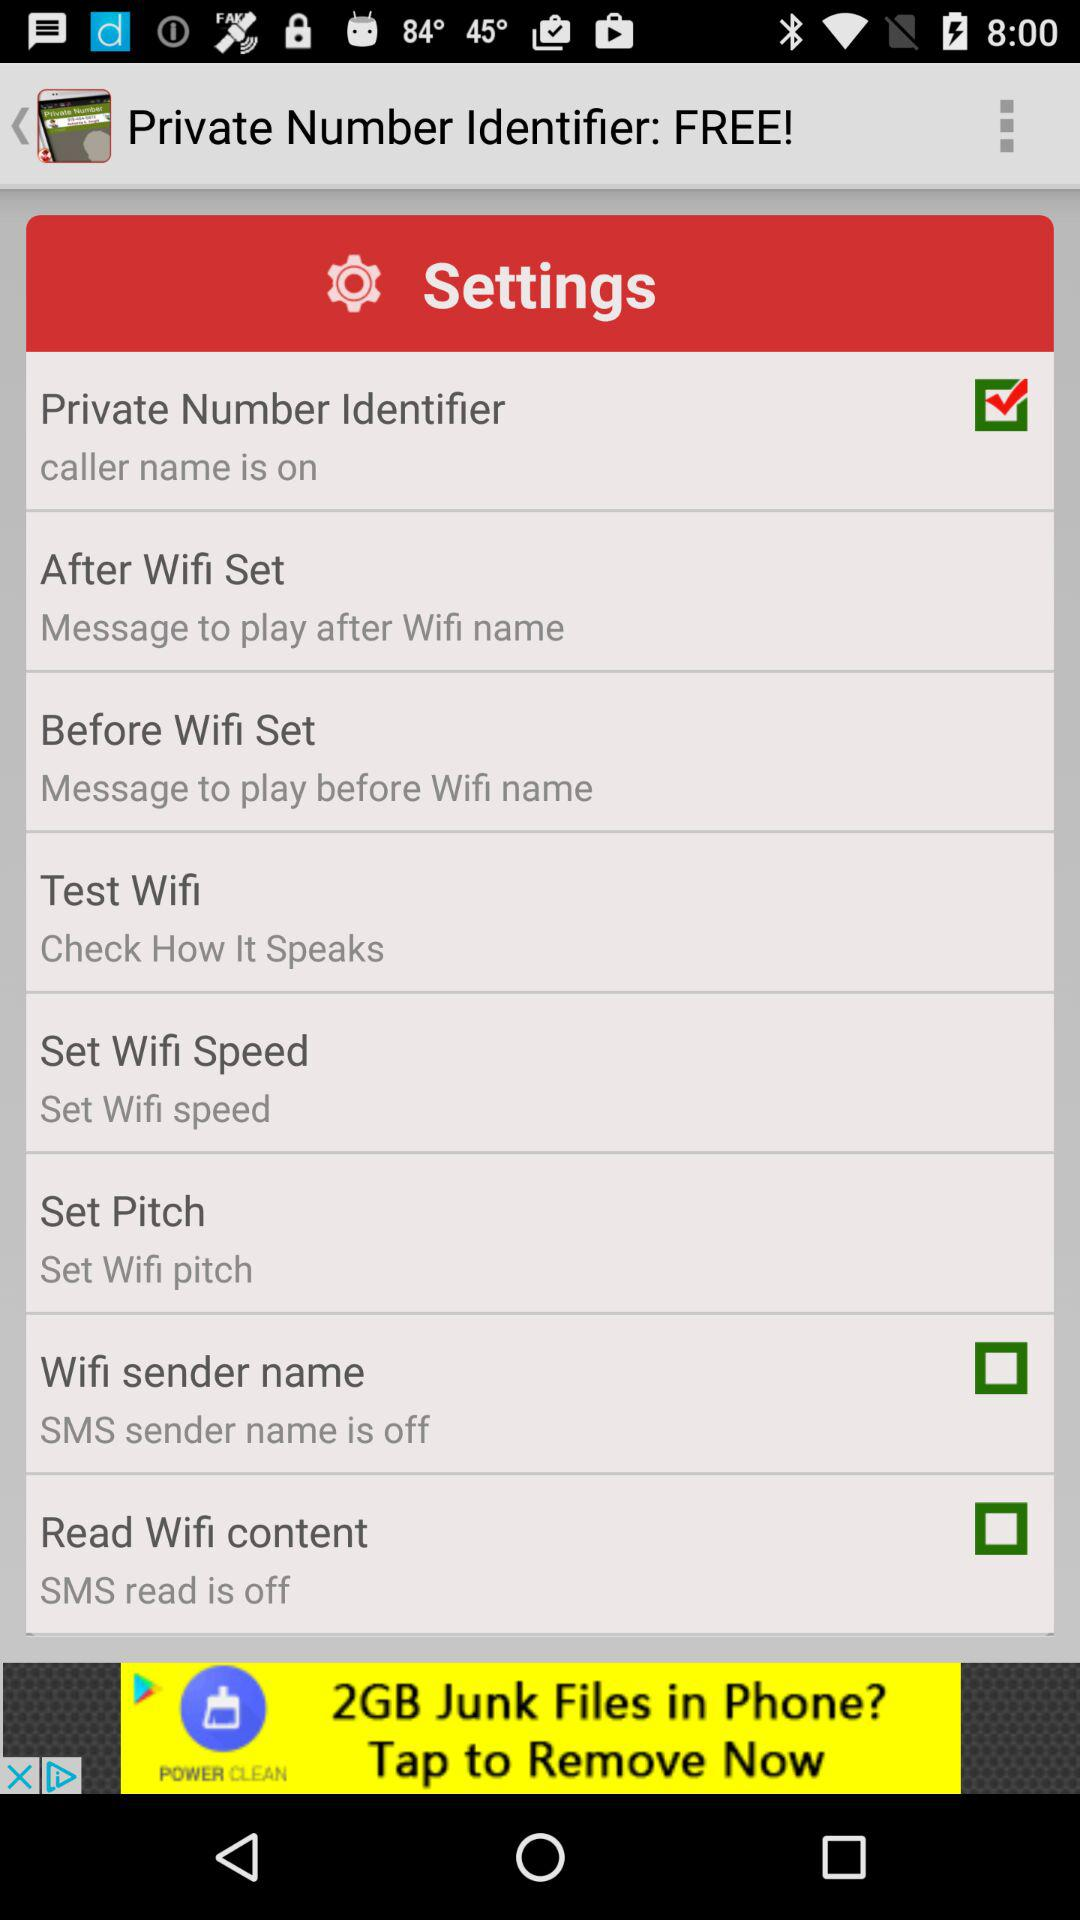What is the current status of the "Read Wifi content"? The status is "off". 